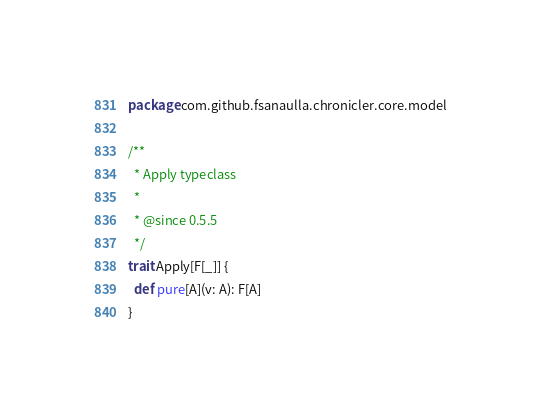<code> <loc_0><loc_0><loc_500><loc_500><_Scala_>package com.github.fsanaulla.chronicler.core.model

/**
  * Apply typeclass
  *
  * @since 0.5.5
  */
trait Apply[F[_]] {
  def pure[A](v: A): F[A]
}
</code> 